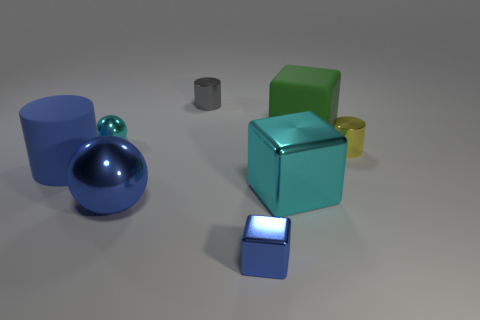Subtract all yellow cylinders. How many cylinders are left? 2 Subtract all blue cubes. How many cubes are left? 2 Add 2 tiny blue blocks. How many objects exist? 10 Subtract 1 cylinders. How many cylinders are left? 2 Subtract all purple cylinders. Subtract all cyan cubes. How many cylinders are left? 3 Add 6 big objects. How many big objects exist? 10 Subtract 0 green spheres. How many objects are left? 8 Subtract all spheres. How many objects are left? 6 Subtract all small yellow metal cylinders. Subtract all tiny blue metallic cubes. How many objects are left? 6 Add 4 large green objects. How many large green objects are left? 5 